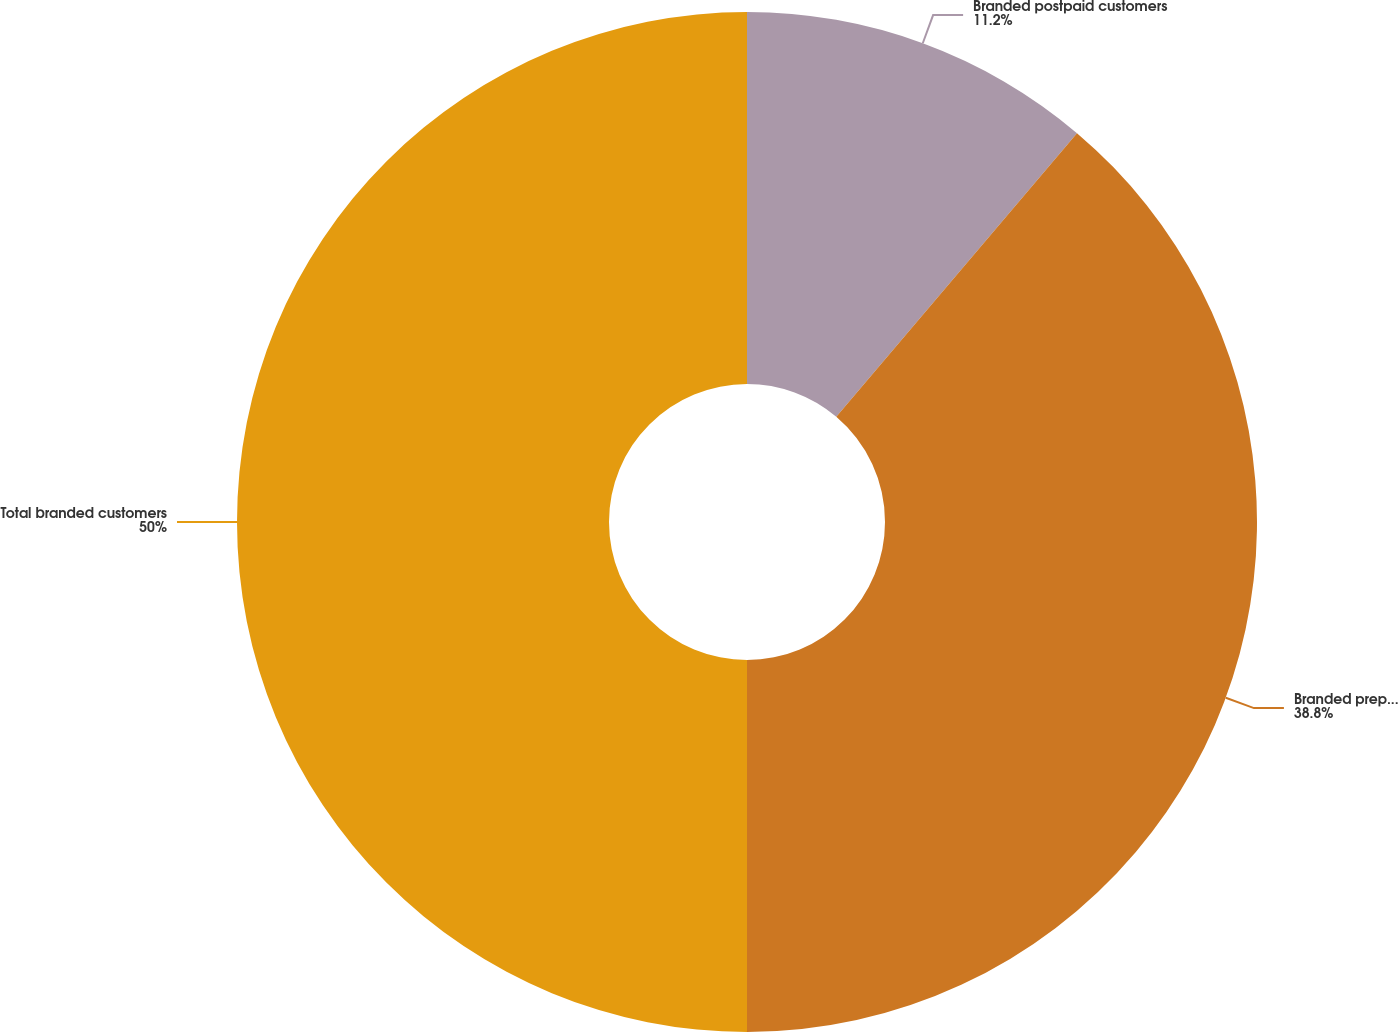<chart> <loc_0><loc_0><loc_500><loc_500><pie_chart><fcel>Branded postpaid customers<fcel>Branded prepaid customers<fcel>Total branded customers<nl><fcel>11.2%<fcel>38.8%<fcel>50.0%<nl></chart> 